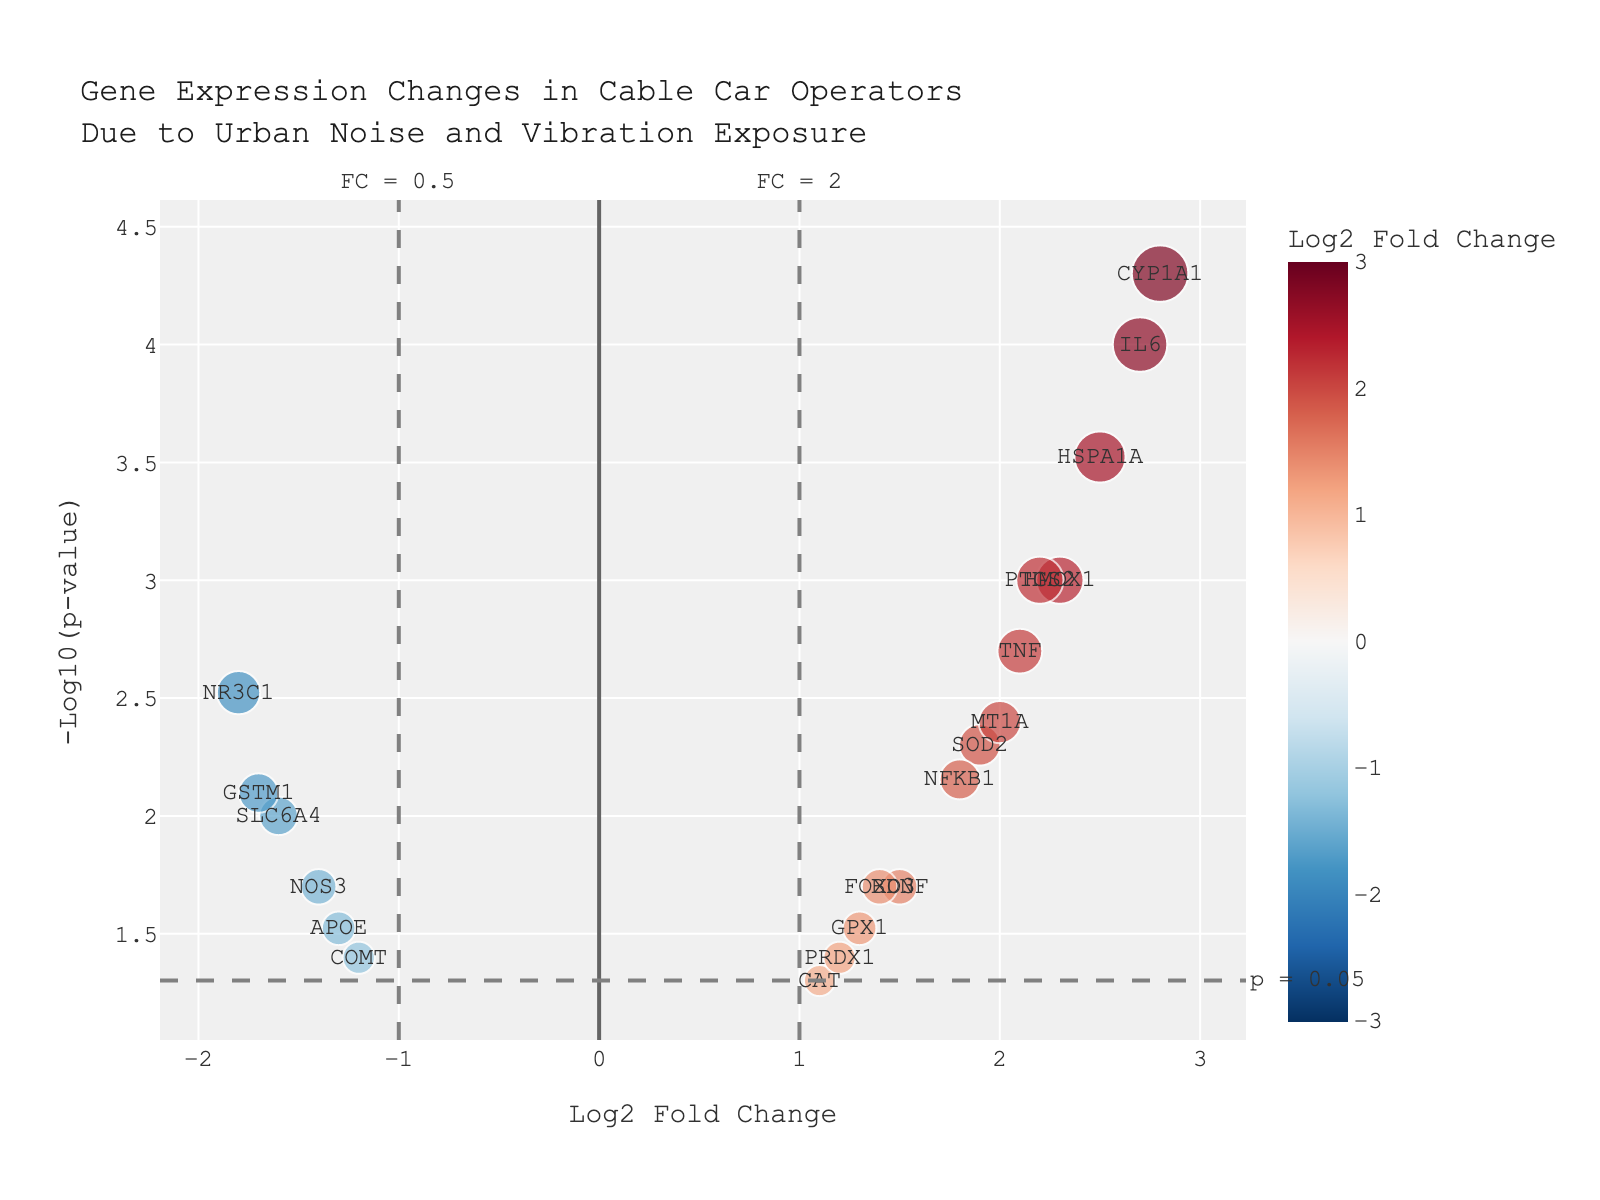What is the title of the plot? The title of the plot is usually displayed at the top, providing a brief description of what the plot represents. In this case, you can see the title "Gene Expression Changes in Cable Car Operators Due to Urban Noise and Vibration Exposure" at the top of the figure.
Answer: Gene Expression Changes in Cable Car Operators Due to Urban Noise and Vibration Exposure How many genes have a fold change greater than 2? By inspecting the figure, you can look for points that are positioned to the right of the vertical line x=1 (indicating fold change of 2). These points represent genes with a fold change greater than 2.
Answer: 5 Which gene has the highest log2 fold change? The highest log2 fold change is visible as the point with the furthest right x-value. You can check the hover labels or text to find the gene name. In this plot, the highest value is approximately 2.8, corresponding to the gene CYP1A1.
Answer: CYP1A1 Which gene has the most significant p-value? The most significant p-value corresponds to the highest y-value on the plot. In this case, the gene with the highest y-value of approximately '-log10(p-value)' is CYP1A1, with a -log10(p-value) of 4.3, making it the most significant.
Answer: CYP1A1 How does the fold change of TNF compare to SLC6A4? Compare the position of TNF and SLC6A4 on the x-axis. TNF is located at approximately 2.1 (positive fold change), whereas SLC6A4 is at around -1.6 (negative fold change). This tells us TNF has a positive fold change while SLC6A4 has a negative fold change.
Answer: TNF has a higher fold change than SLC6A4 Which genes have a log2 fold change near 1? Look for points close to the x = 1 mark. You can use the hover labels to identify the genes. From the plot, the genes near log2 fold change of 1 include BDNF, FOXO3, CAT, and PRDX1.
Answer: BDNF, FOXO3, CAT, PRDX1 Of the top five significant genes, how many have positive fold changes? Identify the top five significant genes by their highest -log10(p-value). Then, count the ones with a positive log2 fold change (x-axis value). The top five are CYP1A1, IL6, HSPA1A, TNF, and HMOX1, all of which have positive fold changes.
Answer: 5 What is the range of the fold changes displayed in this plot? Determine the minimum and maximum x-values (log2 fold changes) from the plot. The minimum value is approximately -1.8 (by NR3C1), and the maximum value is about 2.8 (by CYP1A1). Therefore, the range is -1.8 to 2.8.
Answer: -1.8 to 2.8 